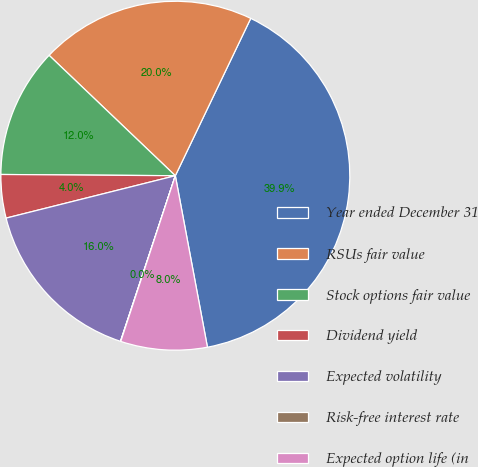<chart> <loc_0><loc_0><loc_500><loc_500><pie_chart><fcel>Year ended December 31<fcel>RSUs fair value<fcel>Stock options fair value<fcel>Dividend yield<fcel>Expected volatility<fcel>Risk-free interest rate<fcel>Expected option life (in<nl><fcel>39.94%<fcel>19.99%<fcel>12.01%<fcel>4.02%<fcel>16.0%<fcel>0.03%<fcel>8.01%<nl></chart> 